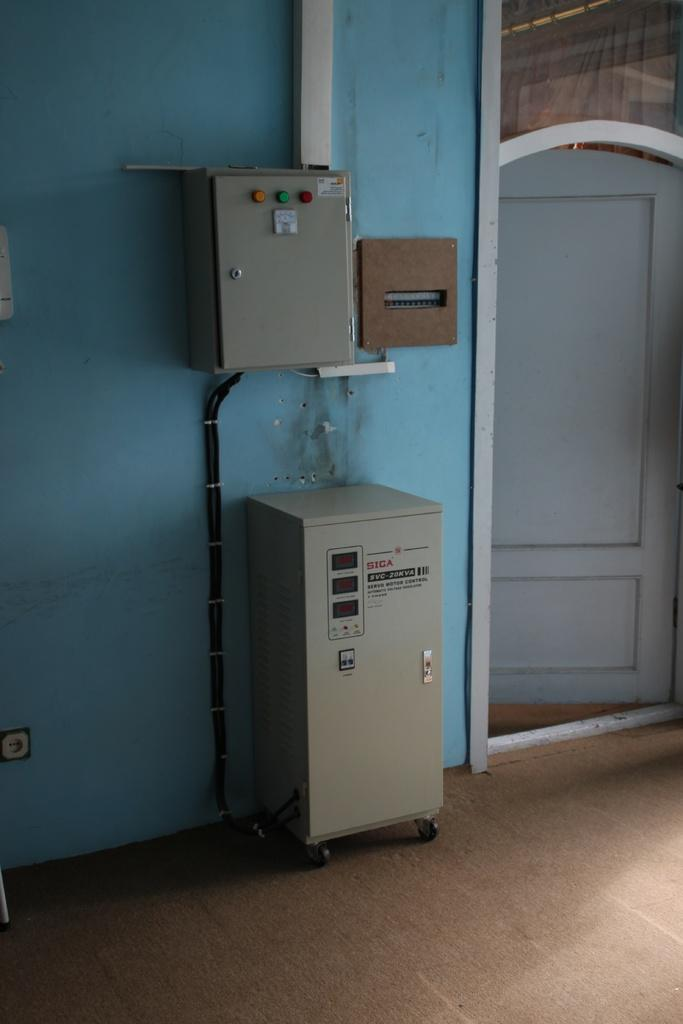What type of equipment is visible in the image? There are control panel boards in the image. What is the background of the image made of? There is a wall in the image. Is there any entrance or exit visible in the image? Yes, there is a door in the image. How much money is being pumped into the fuel tank in the image? There is no money, pump, pump, or fuel tank present in the image. 